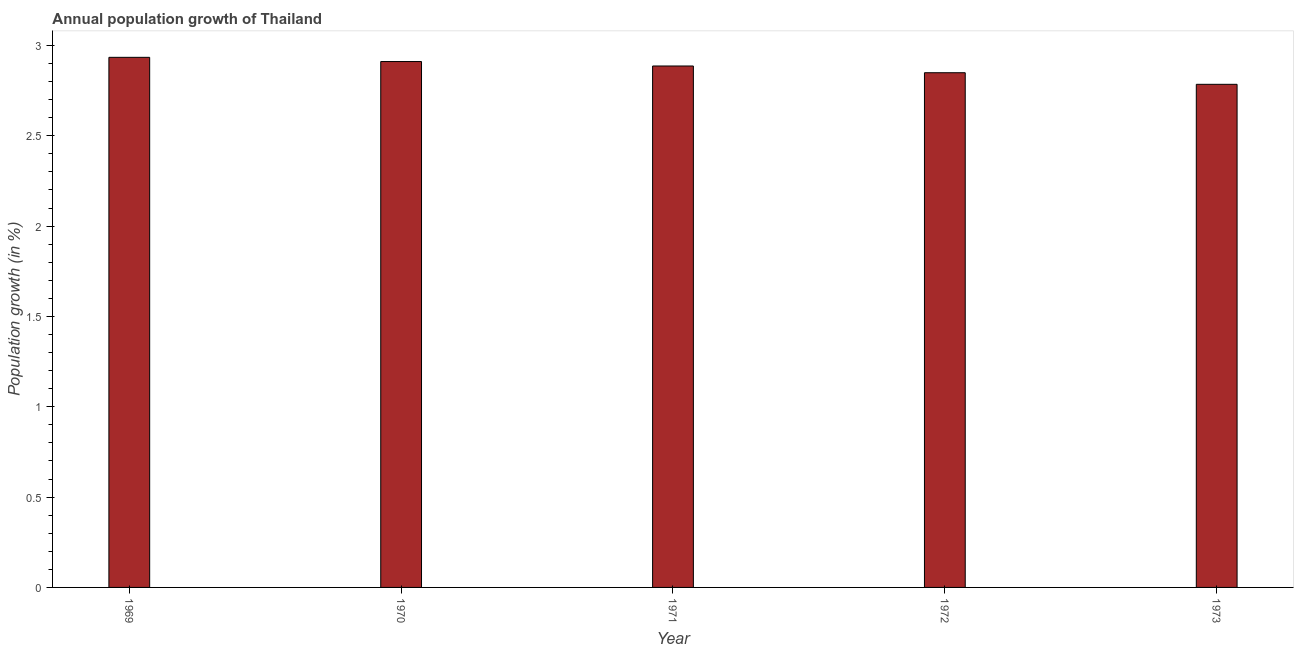Does the graph contain any zero values?
Your answer should be very brief. No. Does the graph contain grids?
Provide a succinct answer. No. What is the title of the graph?
Offer a terse response. Annual population growth of Thailand. What is the label or title of the Y-axis?
Provide a succinct answer. Population growth (in %). What is the population growth in 1969?
Offer a terse response. 2.93. Across all years, what is the maximum population growth?
Keep it short and to the point. 2.93. Across all years, what is the minimum population growth?
Your response must be concise. 2.78. In which year was the population growth maximum?
Keep it short and to the point. 1969. In which year was the population growth minimum?
Offer a very short reply. 1973. What is the sum of the population growth?
Your answer should be compact. 14.36. What is the difference between the population growth in 1969 and 1973?
Give a very brief answer. 0.15. What is the average population growth per year?
Your answer should be very brief. 2.87. What is the median population growth?
Make the answer very short. 2.89. What is the ratio of the population growth in 1969 to that in 1971?
Provide a short and direct response. 1.02. What is the difference between the highest and the second highest population growth?
Make the answer very short. 0.02. Is the sum of the population growth in 1970 and 1971 greater than the maximum population growth across all years?
Offer a terse response. Yes. In how many years, is the population growth greater than the average population growth taken over all years?
Ensure brevity in your answer.  3. How many bars are there?
Your answer should be very brief. 5. What is the difference between two consecutive major ticks on the Y-axis?
Keep it short and to the point. 0.5. What is the Population growth (in %) in 1969?
Offer a terse response. 2.93. What is the Population growth (in %) of 1970?
Offer a very short reply. 2.91. What is the Population growth (in %) of 1971?
Your answer should be very brief. 2.89. What is the Population growth (in %) in 1972?
Provide a succinct answer. 2.85. What is the Population growth (in %) in 1973?
Make the answer very short. 2.78. What is the difference between the Population growth (in %) in 1969 and 1970?
Make the answer very short. 0.02. What is the difference between the Population growth (in %) in 1969 and 1971?
Your response must be concise. 0.05. What is the difference between the Population growth (in %) in 1969 and 1972?
Your response must be concise. 0.09. What is the difference between the Population growth (in %) in 1969 and 1973?
Give a very brief answer. 0.15. What is the difference between the Population growth (in %) in 1970 and 1971?
Your answer should be compact. 0.02. What is the difference between the Population growth (in %) in 1970 and 1972?
Your answer should be compact. 0.06. What is the difference between the Population growth (in %) in 1970 and 1973?
Provide a succinct answer. 0.13. What is the difference between the Population growth (in %) in 1971 and 1972?
Provide a short and direct response. 0.04. What is the difference between the Population growth (in %) in 1971 and 1973?
Your response must be concise. 0.1. What is the difference between the Population growth (in %) in 1972 and 1973?
Provide a succinct answer. 0.06. What is the ratio of the Population growth (in %) in 1969 to that in 1971?
Your answer should be compact. 1.02. What is the ratio of the Population growth (in %) in 1969 to that in 1972?
Your answer should be compact. 1.03. What is the ratio of the Population growth (in %) in 1969 to that in 1973?
Offer a very short reply. 1.05. What is the ratio of the Population growth (in %) in 1970 to that in 1971?
Give a very brief answer. 1.01. What is the ratio of the Population growth (in %) in 1970 to that in 1973?
Offer a very short reply. 1.04. What is the ratio of the Population growth (in %) in 1971 to that in 1972?
Your answer should be compact. 1.01. What is the ratio of the Population growth (in %) in 1971 to that in 1973?
Offer a terse response. 1.04. What is the ratio of the Population growth (in %) in 1972 to that in 1973?
Ensure brevity in your answer.  1.02. 